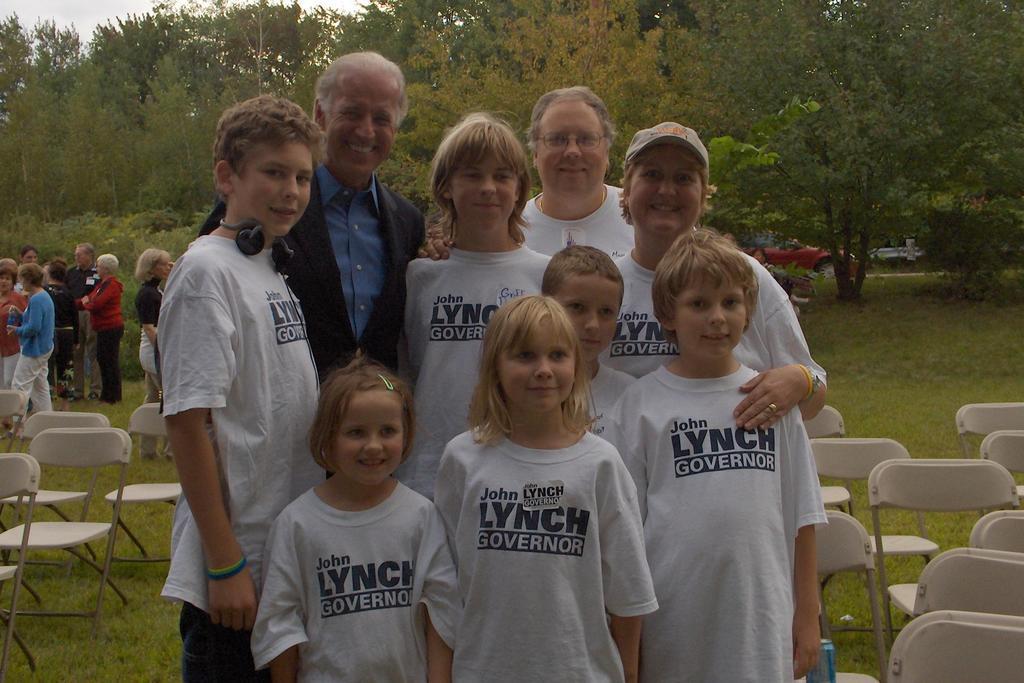How would you summarize this image in a sentence or two? In this image I can see a group of people are standing they wore white color t-shirts. There are chairs on either side at the back side there are trees. 